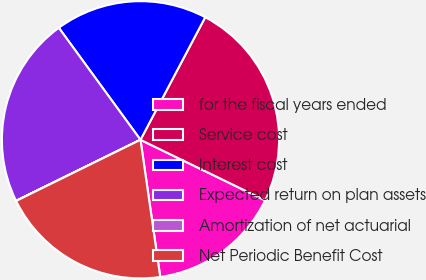<chart> <loc_0><loc_0><loc_500><loc_500><pie_chart><fcel>for the fiscal years ended<fcel>Service cost<fcel>Interest cost<fcel>Expected return on plan assets<fcel>Amortization of net actuarial<fcel>Net Periodic Benefit Cost<nl><fcel>15.53%<fcel>24.46%<fcel>17.76%<fcel>22.23%<fcel>0.02%<fcel>20.0%<nl></chart> 